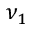Convert formula to latex. <formula><loc_0><loc_0><loc_500><loc_500>\nu _ { 1 }</formula> 